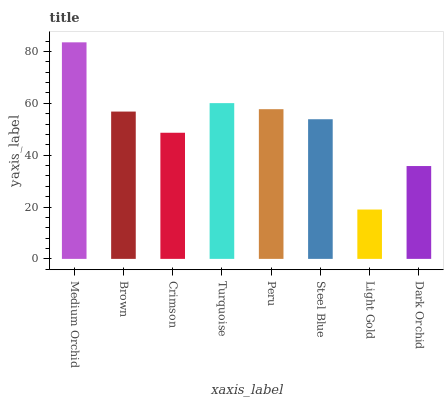Is Light Gold the minimum?
Answer yes or no. Yes. Is Medium Orchid the maximum?
Answer yes or no. Yes. Is Brown the minimum?
Answer yes or no. No. Is Brown the maximum?
Answer yes or no. No. Is Medium Orchid greater than Brown?
Answer yes or no. Yes. Is Brown less than Medium Orchid?
Answer yes or no. Yes. Is Brown greater than Medium Orchid?
Answer yes or no. No. Is Medium Orchid less than Brown?
Answer yes or no. No. Is Brown the high median?
Answer yes or no. Yes. Is Steel Blue the low median?
Answer yes or no. Yes. Is Turquoise the high median?
Answer yes or no. No. Is Crimson the low median?
Answer yes or no. No. 